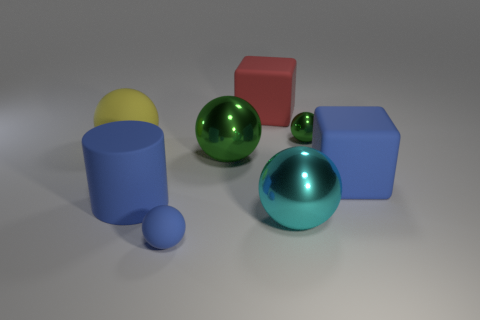Subtract all red cylinders. How many green balls are left? 2 Subtract all tiny green shiny spheres. How many spheres are left? 4 Subtract all cyan balls. How many balls are left? 4 Subtract 3 spheres. How many spheres are left? 2 Add 1 small cyan shiny objects. How many objects exist? 9 Subtract all cyan spheres. Subtract all yellow cylinders. How many spheres are left? 4 Subtract all cylinders. How many objects are left? 7 Subtract 0 cyan blocks. How many objects are left? 8 Subtract all big green shiny spheres. Subtract all blue matte things. How many objects are left? 4 Add 1 small green things. How many small green things are left? 2 